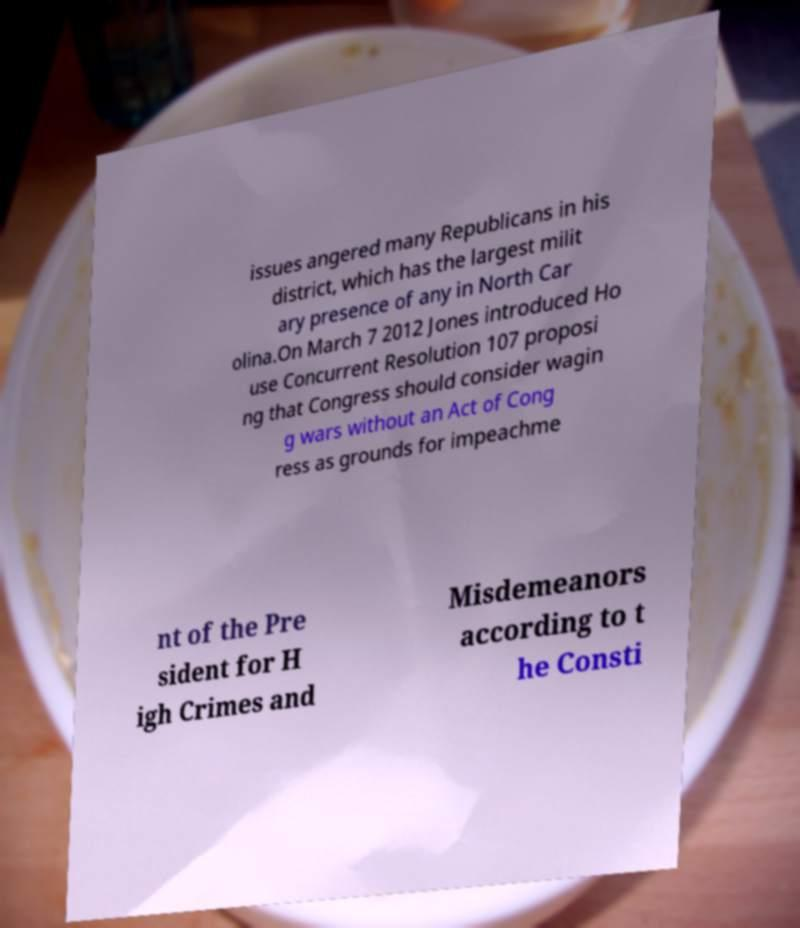Could you extract and type out the text from this image? issues angered many Republicans in his district, which has the largest milit ary presence of any in North Car olina.On March 7 2012 Jones introduced Ho use Concurrent Resolution 107 proposi ng that Congress should consider wagin g wars without an Act of Cong ress as grounds for impeachme nt of the Pre sident for H igh Crimes and Misdemeanors according to t he Consti 